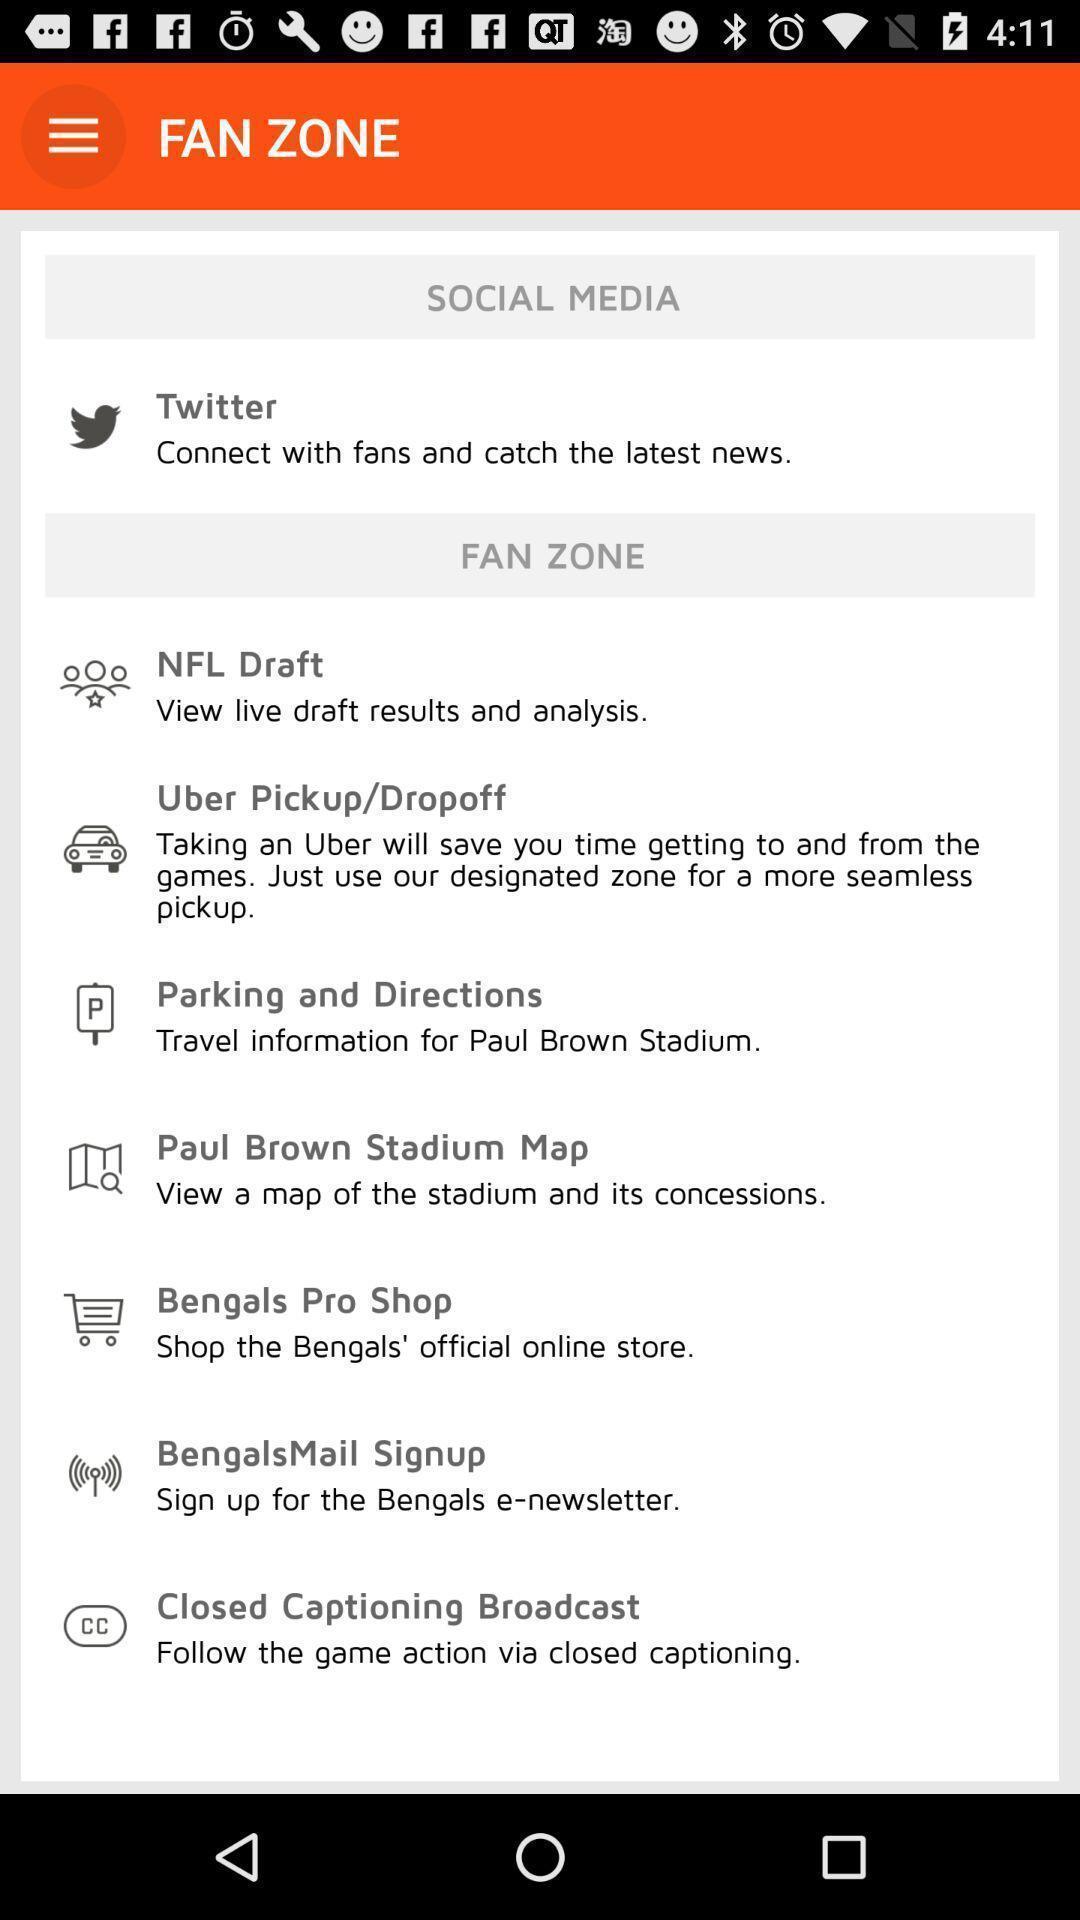Provide a textual representation of this image. Page shows different categories in the tour app. 